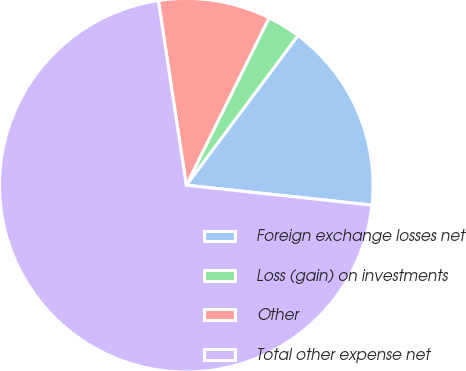Convert chart to OTSL. <chart><loc_0><loc_0><loc_500><loc_500><pie_chart><fcel>Foreign exchange losses net<fcel>Loss (gain) on investments<fcel>Other<fcel>Total other expense net<nl><fcel>16.5%<fcel>2.89%<fcel>9.7%<fcel>70.91%<nl></chart> 